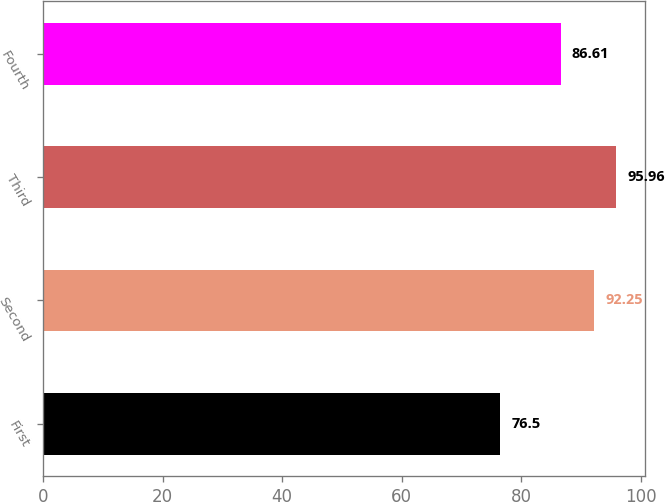Convert chart to OTSL. <chart><loc_0><loc_0><loc_500><loc_500><bar_chart><fcel>First<fcel>Second<fcel>Third<fcel>Fourth<nl><fcel>76.5<fcel>92.25<fcel>95.96<fcel>86.61<nl></chart> 